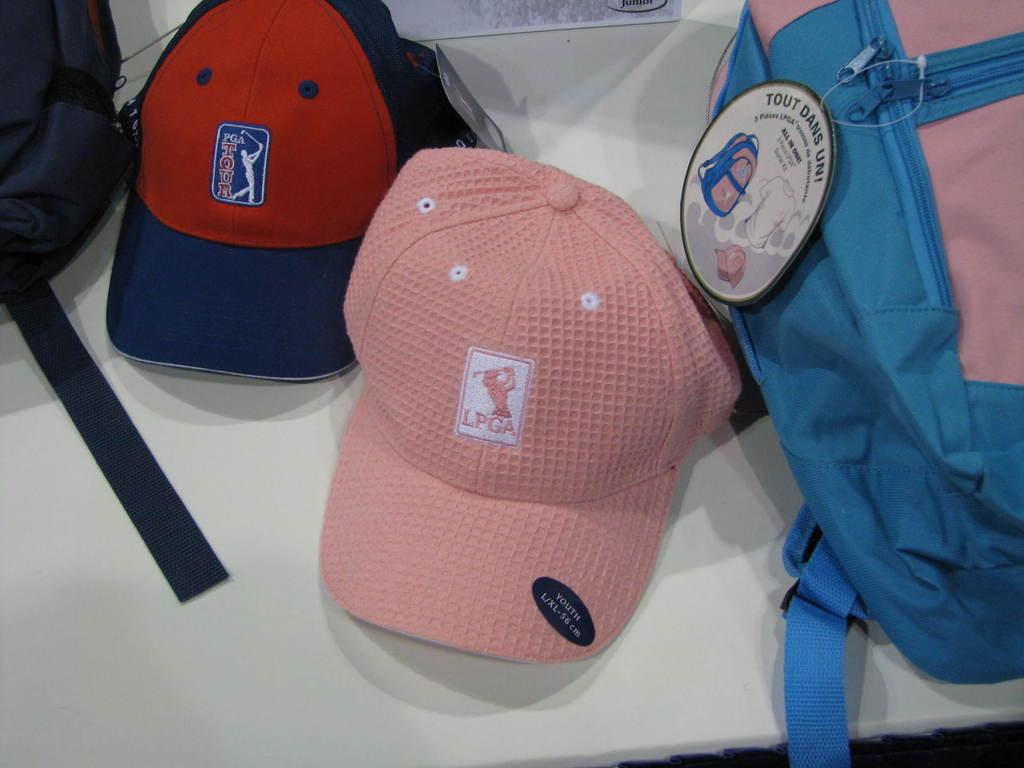<image>
Render a clear and concise summary of the photo. Two PGA caps are next to a pink and blue bag. 